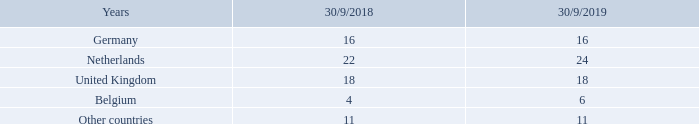Changes in parameters on the basis of actuarial calculations led to a total increase in the present value of defined benefit obligations by €247 million (2017/18: €−24 million). Most of the effects result from the reduction of the applied invoice rates.
The weighted average term of defined benefit commitments for the countries with material pension obligations amounts to:
What are the changes in parameter based on? On the basis of actuarial calculations. What did the changes in parameters on the basis of actuarial calculations lead to? A total increase in the present value of defined benefit obligations by €247 million (2017/18: €−24 million). most of the effects result from the reduction of the applied invoice rates. The weighted average term of defined benefit commitments for which countries is provided? Germany, netherlands, united kingdom, belgium, other countries. In which year was the amount in Belgium larger? 6>4
Answer: 2019. What was the change in the amount for Belgium in  FY2019 from FY2018? 6-4
Answer: 2. What was the percentage change in the amount for Belgium in  FY2019 from FY2018?
Answer scale should be: percent. (6-4)/4
Answer: 50. 